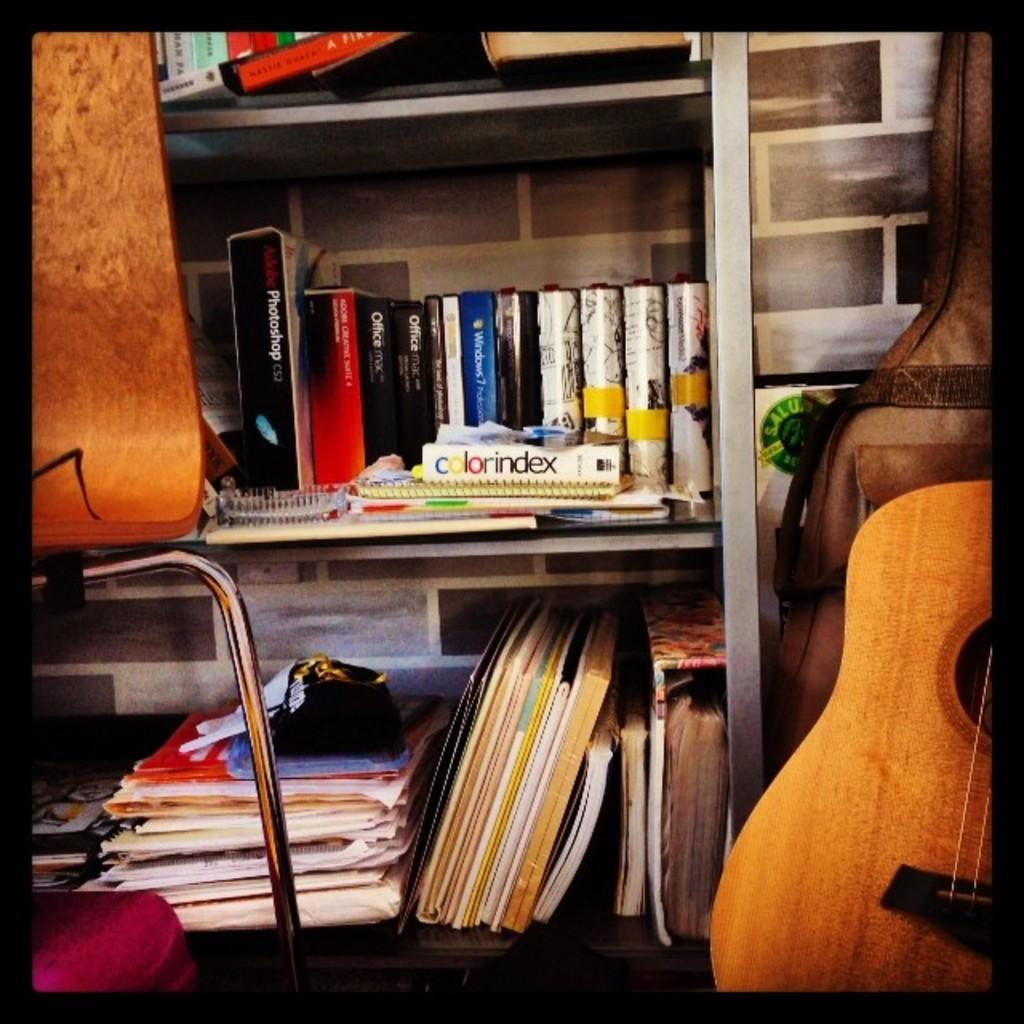<image>
Give a short and clear explanation of the subsequent image. A book that says colorindex sits sideways on a crowded bookshelf. 